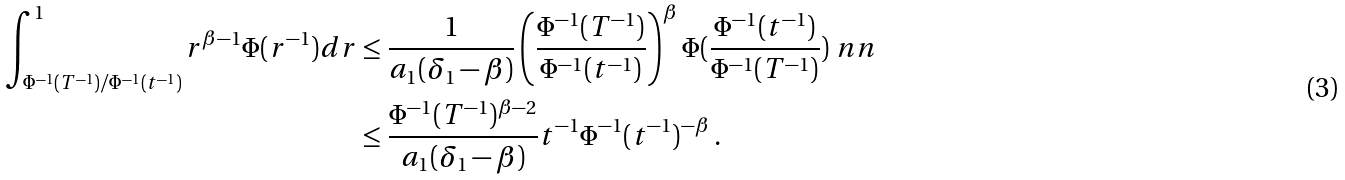Convert formula to latex. <formula><loc_0><loc_0><loc_500><loc_500>\int _ { \Phi ^ { - 1 } ( T ^ { - 1 } ) / \Phi ^ { - 1 } ( t ^ { - 1 } ) } ^ { 1 } r ^ { \beta - 1 } \Phi ( r ^ { - 1 } ) d r & \leq \frac { 1 } { a _ { 1 } ( \delta _ { 1 } - \beta ) } \left ( \frac { \Phi ^ { - 1 } ( T ^ { - 1 } ) } { \Phi ^ { - 1 } ( t ^ { - 1 } ) } \right ) ^ { \beta } \Phi ( \frac { \Phi ^ { - 1 } ( t ^ { - 1 } ) } { \Phi ^ { - 1 } ( T ^ { - 1 } ) } ) \ n n \\ & \leq \frac { \Phi ^ { - 1 } ( T ^ { - 1 } ) ^ { \beta - 2 } } { a _ { 1 } ( \delta _ { 1 } - \beta ) } t ^ { - 1 } \Phi ^ { - 1 } ( t ^ { - 1 } ) ^ { - \beta } \, .</formula> 